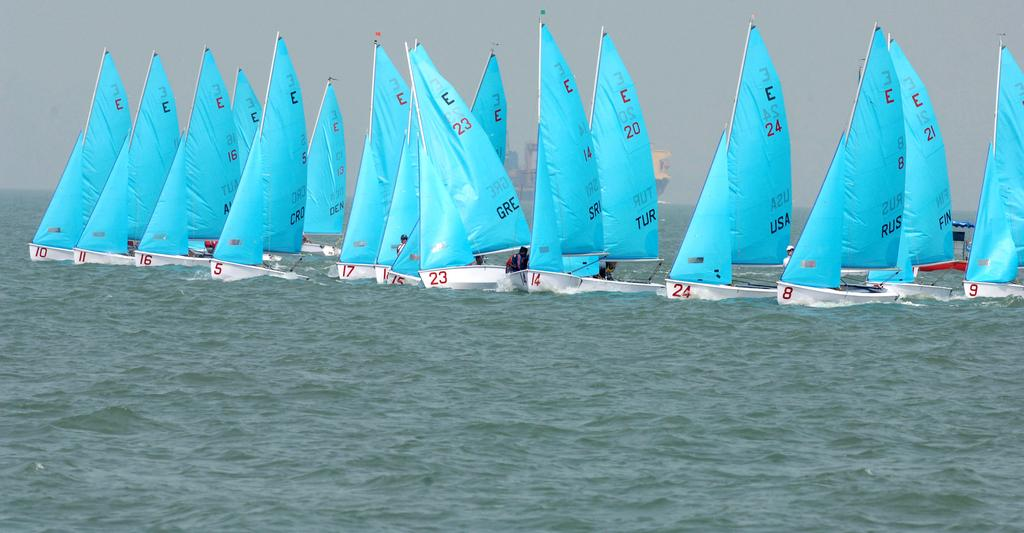What is the main setting of the picture? There is an ocean in the picture. What can be seen in the ocean? There are boats in the ocean. What color are the boats? The boats are blue in color. Are there any people on the boats? Yes, there are people on the boats. What is visible in the background of the picture? There is a sky and a ship visible in the background. What type of plough is being used to harvest crops in the image? There is no plough present in the image; it features an ocean with boats and a ship in the background. Can you see any branches from trees in the image? There are no branches from trees visible in the image. 